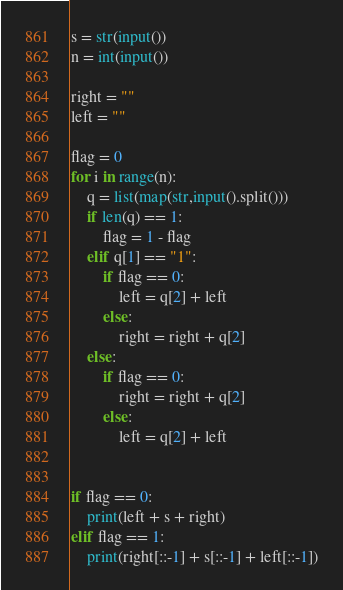<code> <loc_0><loc_0><loc_500><loc_500><_Python_>s = str(input())
n = int(input())

right = ""
left = ""

flag = 0
for i in range(n):
    q = list(map(str,input().split()))
    if len(q) == 1:
        flag = 1 - flag 
    elif q[1] == "1":
        if flag == 0:
            left = q[2] + left
        else:
            right = right + q[2]
    else:
        if flag == 0:
            right = right + q[2]
        else:
            left = q[2] + left


if flag == 0:
    print(left + s + right)
elif flag == 1:
    print(right[::-1] + s[::-1] + left[::-1])</code> 